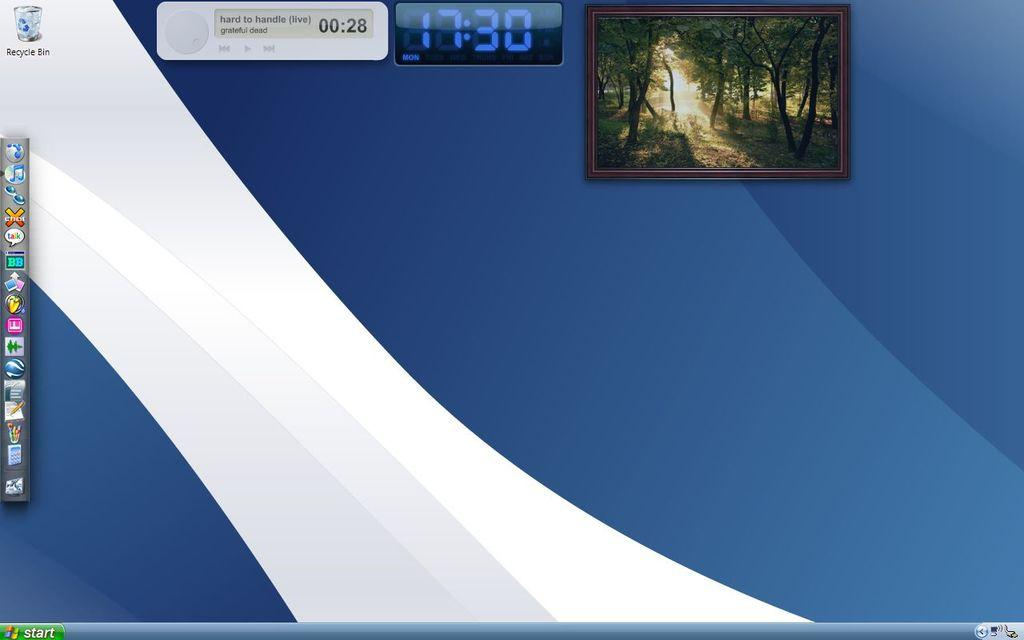What is the main subject of the image? The main subject of the image is a computer screen. What type of image is displayed on the screen? There is a photo frame with trees on the screen. Where are the icons located on the screen? The icons are on the left side of the screen. What additional information is displayed on the screen? The time is displayed on the top side of the screen. How many snails can be seen crawling on the screen? There are no snails visible on the screen. 